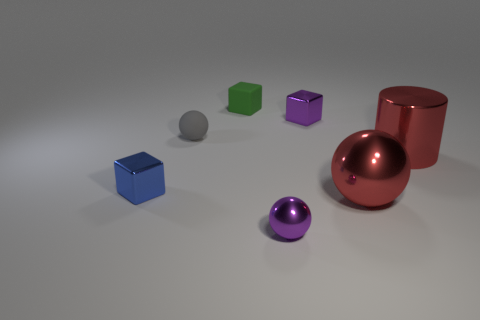Add 2 small cyan metallic blocks. How many objects exist? 9 Subtract all spheres. How many objects are left? 4 Subtract 1 red cylinders. How many objects are left? 6 Subtract all tiny gray matte objects. Subtract all small purple things. How many objects are left? 4 Add 3 large metal objects. How many large metal objects are left? 5 Add 3 small purple metallic balls. How many small purple metallic balls exist? 4 